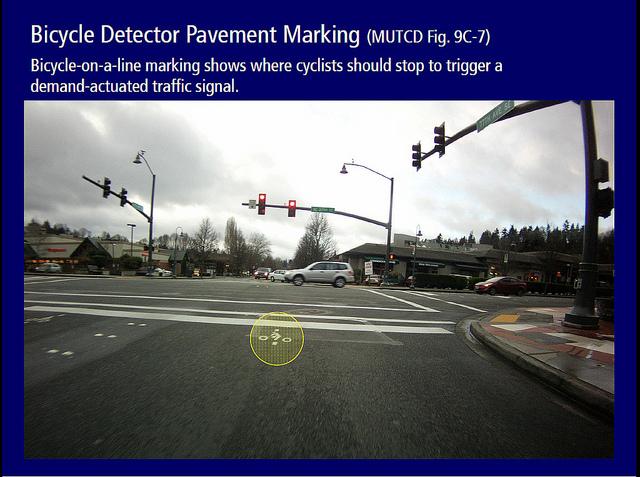What is the yellow thing in this image?
Write a very short answer. Pointer. Is there a car in the intersection?
Answer briefly. Yes. Is there a pasture in the picture?
Write a very short answer. No. Does the car in the intersection have a green light?
Concise answer only. Yes. What is blue in this photo?
Concise answer only. Border. What do the red lights mean?
Give a very brief answer. Stop. 